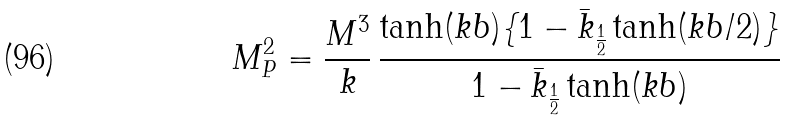Convert formula to latex. <formula><loc_0><loc_0><loc_500><loc_500>M _ { P } ^ { 2 } = \frac { M ^ { 3 } } { k } \, \frac { \tanh ( k b ) \{ 1 - \bar { k } _ { \frac { 1 } { 2 } } \tanh ( k b / 2 ) \} } { 1 - \bar { k } _ { \frac { 1 } { 2 } } \tanh ( k b ) }</formula> 